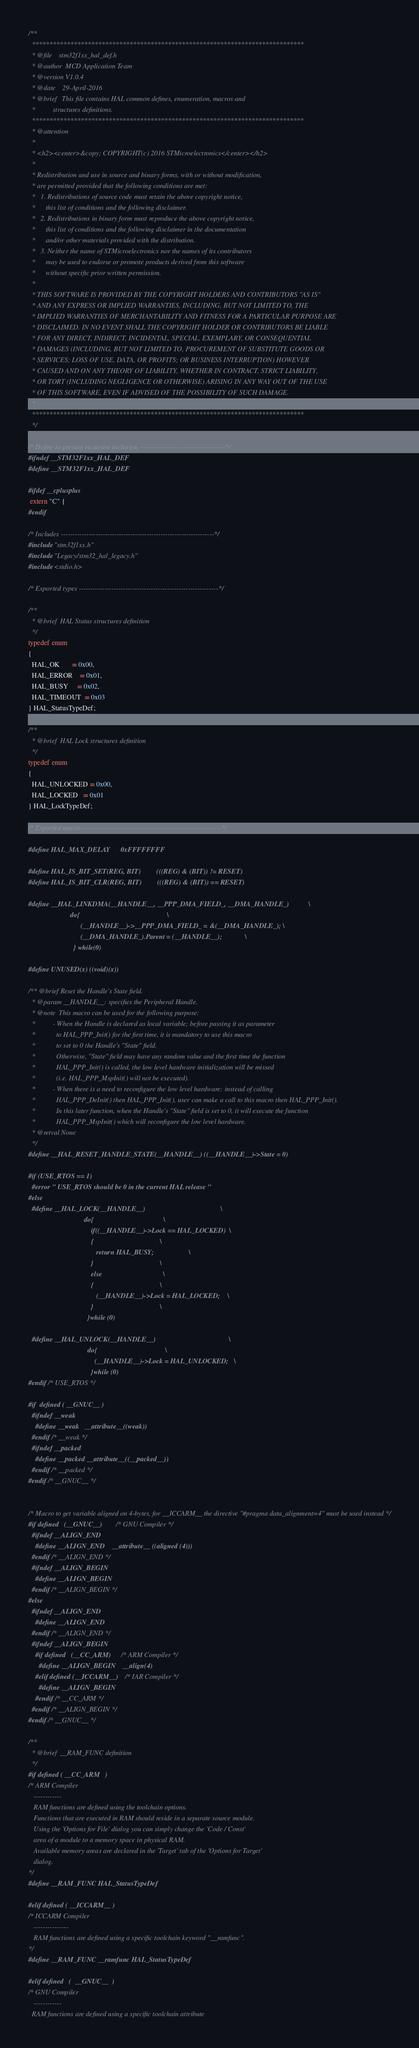<code> <loc_0><loc_0><loc_500><loc_500><_C_>/**
  ******************************************************************************
  * @file    stm32f1xx_hal_def.h
  * @author  MCD Application Team
  * @version V1.0.4
  * @date    29-April-2016
  * @brief   This file contains HAL common defines, enumeration, macros and 
  *          structures definitions. 
  ******************************************************************************
  * @attention
  *
  * <h2><center>&copy; COPYRIGHT(c) 2016 STMicroelectronics</center></h2>
  *
  * Redistribution and use in source and binary forms, with or without modification,
  * are permitted provided that the following conditions are met:
  *   1. Redistributions of source code must retain the above copyright notice,
  *      this list of conditions and the following disclaimer.
  *   2. Redistributions in binary form must reproduce the above copyright notice,
  *      this list of conditions and the following disclaimer in the documentation
  *      and/or other materials provided with the distribution.
  *   3. Neither the name of STMicroelectronics nor the names of its contributors
  *      may be used to endorse or promote products derived from this software
  *      without specific prior written permission.
  *
  * THIS SOFTWARE IS PROVIDED BY THE COPYRIGHT HOLDERS AND CONTRIBUTORS "AS IS"
  * AND ANY EXPRESS OR IMPLIED WARRANTIES, INCLUDING, BUT NOT LIMITED TO, THE
  * IMPLIED WARRANTIES OF MERCHANTABILITY AND FITNESS FOR A PARTICULAR PURPOSE ARE
  * DISCLAIMED. IN NO EVENT SHALL THE COPYRIGHT HOLDER OR CONTRIBUTORS BE LIABLE
  * FOR ANY DIRECT, INDIRECT, INCIDENTAL, SPECIAL, EXEMPLARY, OR CONSEQUENTIAL
  * DAMAGES (INCLUDING, BUT NOT LIMITED TO, PROCUREMENT OF SUBSTITUTE GOODS OR
  * SERVICES; LOSS OF USE, DATA, OR PROFITS; OR BUSINESS INTERRUPTION) HOWEVER
  * CAUSED AND ON ANY THEORY OF LIABILITY, WHETHER IN CONTRACT, STRICT LIABILITY,
  * OR TORT (INCLUDING NEGLIGENCE OR OTHERWISE) ARISING IN ANY WAY OUT OF THE USE
  * OF THIS SOFTWARE, EVEN IF ADVISED OF THE POSSIBILITY OF SUCH DAMAGE.
  *
  ******************************************************************************
  */

/* Define to prevent recursive inclusion -------------------------------------*/
#ifndef __STM32F1xx_HAL_DEF
#define __STM32F1xx_HAL_DEF

#ifdef __cplusplus
 extern "C" {
#endif

/* Includes ------------------------------------------------------------------*/
#include "stm32f1xx.h"
#include "Legacy/stm32_hal_legacy.h"
#include <stdio.h>

/* Exported types ------------------------------------------------------------*/

/** 
  * @brief  HAL Status structures definition  
  */  
typedef enum 
{
  HAL_OK       = 0x00,
  HAL_ERROR    = 0x01,
  HAL_BUSY     = 0x02,
  HAL_TIMEOUT  = 0x03
} HAL_StatusTypeDef;

/** 
  * @brief  HAL Lock structures definition  
  */
typedef enum 
{
  HAL_UNLOCKED = 0x00,
  HAL_LOCKED   = 0x01  
} HAL_LockTypeDef;

/* Exported macro ------------------------------------------------------------*/

#define HAL_MAX_DELAY      0xFFFFFFFF

#define HAL_IS_BIT_SET(REG, BIT)         (((REG) & (BIT)) != RESET)
#define HAL_IS_BIT_CLR(REG, BIT)         (((REG) & (BIT)) == RESET)

#define __HAL_LINKDMA(__HANDLE__, __PPP_DMA_FIELD_, __DMA_HANDLE_)           \
                        do{                                                  \
                              (__HANDLE__)->__PPP_DMA_FIELD_ = &(__DMA_HANDLE_); \
                              (__DMA_HANDLE_).Parent = (__HANDLE__);             \
                          } while(0)

#define UNUSED(x) ((void)(x))

/** @brief Reset the Handle's State field.
  * @param __HANDLE__: specifies the Peripheral Handle.
  * @note  This macro can be used for the following purpose: 
  *          - When the Handle is declared as local variable; before passing it as parameter
  *            to HAL_PPP_Init() for the first time, it is mandatory to use this macro 
  *            to set to 0 the Handle's "State" field.
  *            Otherwise, "State" field may have any random value and the first time the function 
  *            HAL_PPP_Init() is called, the low level hardware initialization will be missed
  *            (i.e. HAL_PPP_MspInit() will not be executed).
  *          - When there is a need to reconfigure the low level hardware: instead of calling
  *            HAL_PPP_DeInit() then HAL_PPP_Init(), user can make a call to this macro then HAL_PPP_Init().
  *            In this later function, when the Handle's "State" field is set to 0, it will execute the function
  *            HAL_PPP_MspInit() which will reconfigure the low level hardware.
  * @retval None
  */
#define __HAL_RESET_HANDLE_STATE(__HANDLE__) ((__HANDLE__)->State = 0)

#if (USE_RTOS == 1)
  #error " USE_RTOS should be 0 in the current HAL release "
#else
  #define __HAL_LOCK(__HANDLE__)                                           \
                                do{                                        \
                                    if((__HANDLE__)->Lock == HAL_LOCKED)  \
                                    {                                      \
                                       return HAL_BUSY;                    \
                                    }                                      \
                                    else                                   \
                                    {                                      \
                                       (__HANDLE__)->Lock = HAL_LOCKED;    \
                                    }                                      \
                                  }while (0)

  #define __HAL_UNLOCK(__HANDLE__)                                          \
                                  do{                                       \
                                      (__HANDLE__)->Lock = HAL_UNLOCKED;   \
                                    }while (0)
#endif /* USE_RTOS */

#if  defined ( __GNUC__ )
  #ifndef __weak
    #define __weak   __attribute__((weak))
  #endif /* __weak */
  #ifndef __packed
    #define __packed __attribute__((__packed__))
  #endif /* __packed */
#endif /* __GNUC__ */


/* Macro to get variable aligned on 4-bytes, for __ICCARM__ the directive "#pragma data_alignment=4" must be used instead */
#if defined   (__GNUC__)        /* GNU Compiler */
  #ifndef __ALIGN_END
    #define __ALIGN_END    __attribute__ ((aligned (4)))
  #endif /* __ALIGN_END */
  #ifndef __ALIGN_BEGIN  
    #define __ALIGN_BEGIN
  #endif /* __ALIGN_BEGIN */
#else
  #ifndef __ALIGN_END
    #define __ALIGN_END
  #endif /* __ALIGN_END */
  #ifndef __ALIGN_BEGIN      
    #if defined   (__CC_ARM)      /* ARM Compiler */
      #define __ALIGN_BEGIN    __align(4)  
    #elif defined (__ICCARM__)    /* IAR Compiler */
      #define __ALIGN_BEGIN 
    #endif /* __CC_ARM */
  #endif /* __ALIGN_BEGIN */
#endif /* __GNUC__ */

/** 
  * @brief  __RAM_FUNC definition
  */ 
#if defined ( __CC_ARM   )
/* ARM Compiler
   ------------
   RAM functions are defined using the toolchain options. 
   Functions that are executed in RAM should reside in a separate source module.
   Using the 'Options for File' dialog you can simply change the 'Code / Const' 
   area of a module to a memory space in physical RAM.
   Available memory areas are declared in the 'Target' tab of the 'Options for Target'
   dialog. 
*/
#define __RAM_FUNC HAL_StatusTypeDef 

#elif defined ( __ICCARM__ )
/* ICCARM Compiler
   ---------------
   RAM functions are defined using a specific toolchain keyword "__ramfunc". 
*/
#define __RAM_FUNC __ramfunc HAL_StatusTypeDef

#elif defined   (  __GNUC__  )
/* GNU Compiler
   ------------
  RAM functions are defined using a specific toolchain attribute </code> 